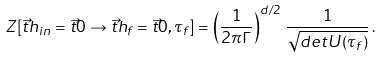Convert formula to latex. <formula><loc_0><loc_0><loc_500><loc_500>Z [ \vec { t } { h } _ { i n } = \vec { t } { 0 } \rightarrow \vec { t } { h } _ { f } = \vec { t } { 0 } , \tau _ { f } ] = \left ( \frac { 1 } { 2 \pi \Gamma } \right ) ^ { d / 2 } \, \frac { 1 } { \sqrt { d e t U ( \tau _ { f } ) } } \, .</formula> 